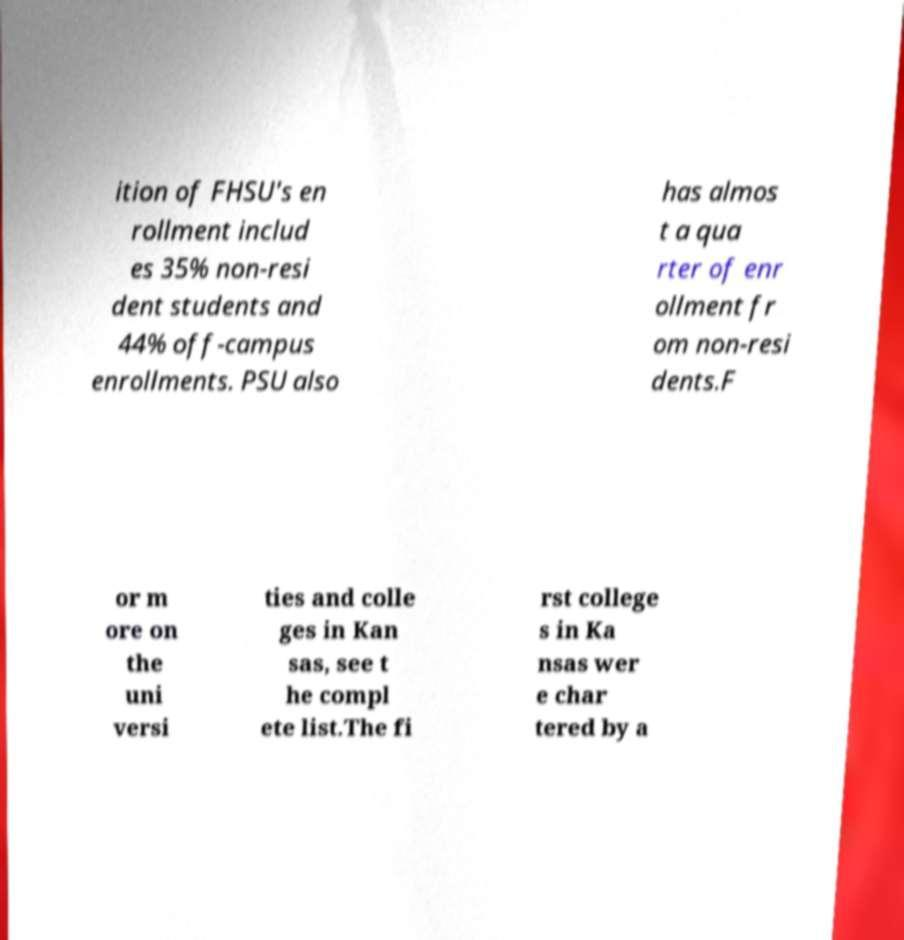What messages or text are displayed in this image? I need them in a readable, typed format. ition of FHSU's en rollment includ es 35% non-resi dent students and 44% off-campus enrollments. PSU also has almos t a qua rter of enr ollment fr om non-resi dents.F or m ore on the uni versi ties and colle ges in Kan sas, see t he compl ete list.The fi rst college s in Ka nsas wer e char tered by a 